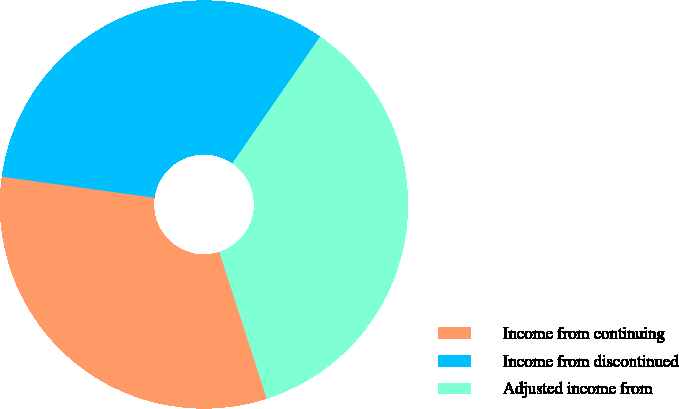Convert chart to OTSL. <chart><loc_0><loc_0><loc_500><loc_500><pie_chart><fcel>Income from continuing<fcel>Income from discontinued<fcel>Adjusted income from<nl><fcel>32.16%<fcel>32.46%<fcel>35.38%<nl></chart> 